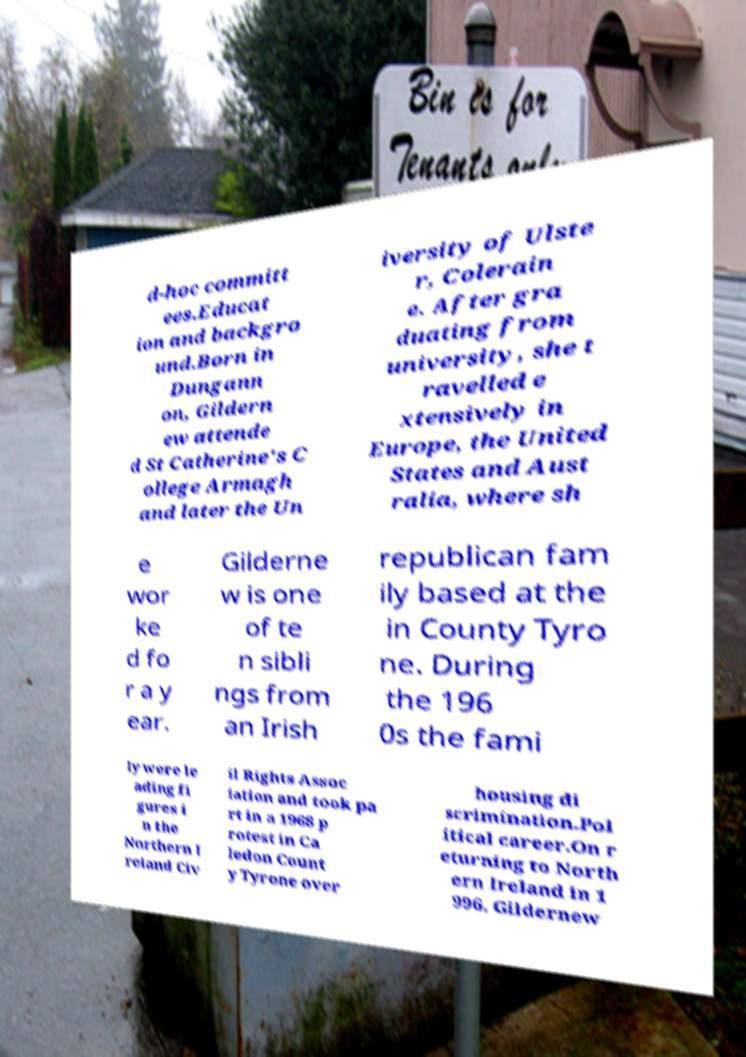Please read and relay the text visible in this image. What does it say? d-hoc committ ees.Educat ion and backgro und.Born in Dungann on, Gildern ew attende d St Catherine's C ollege Armagh and later the Un iversity of Ulste r, Colerain e. After gra duating from university, she t ravelled e xtensively in Europe, the United States and Aust ralia, where sh e wor ke d fo r a y ear. Gilderne w is one of te n sibli ngs from an Irish republican fam ily based at the in County Tyro ne. During the 196 0s the fami ly were le ading fi gures i n the Northern I reland Civ il Rights Assoc iation and took pa rt in a 1968 p rotest in Ca ledon Count y Tyrone over housing di scrimination.Pol itical career.On r eturning to North ern Ireland in 1 996, Gildernew 